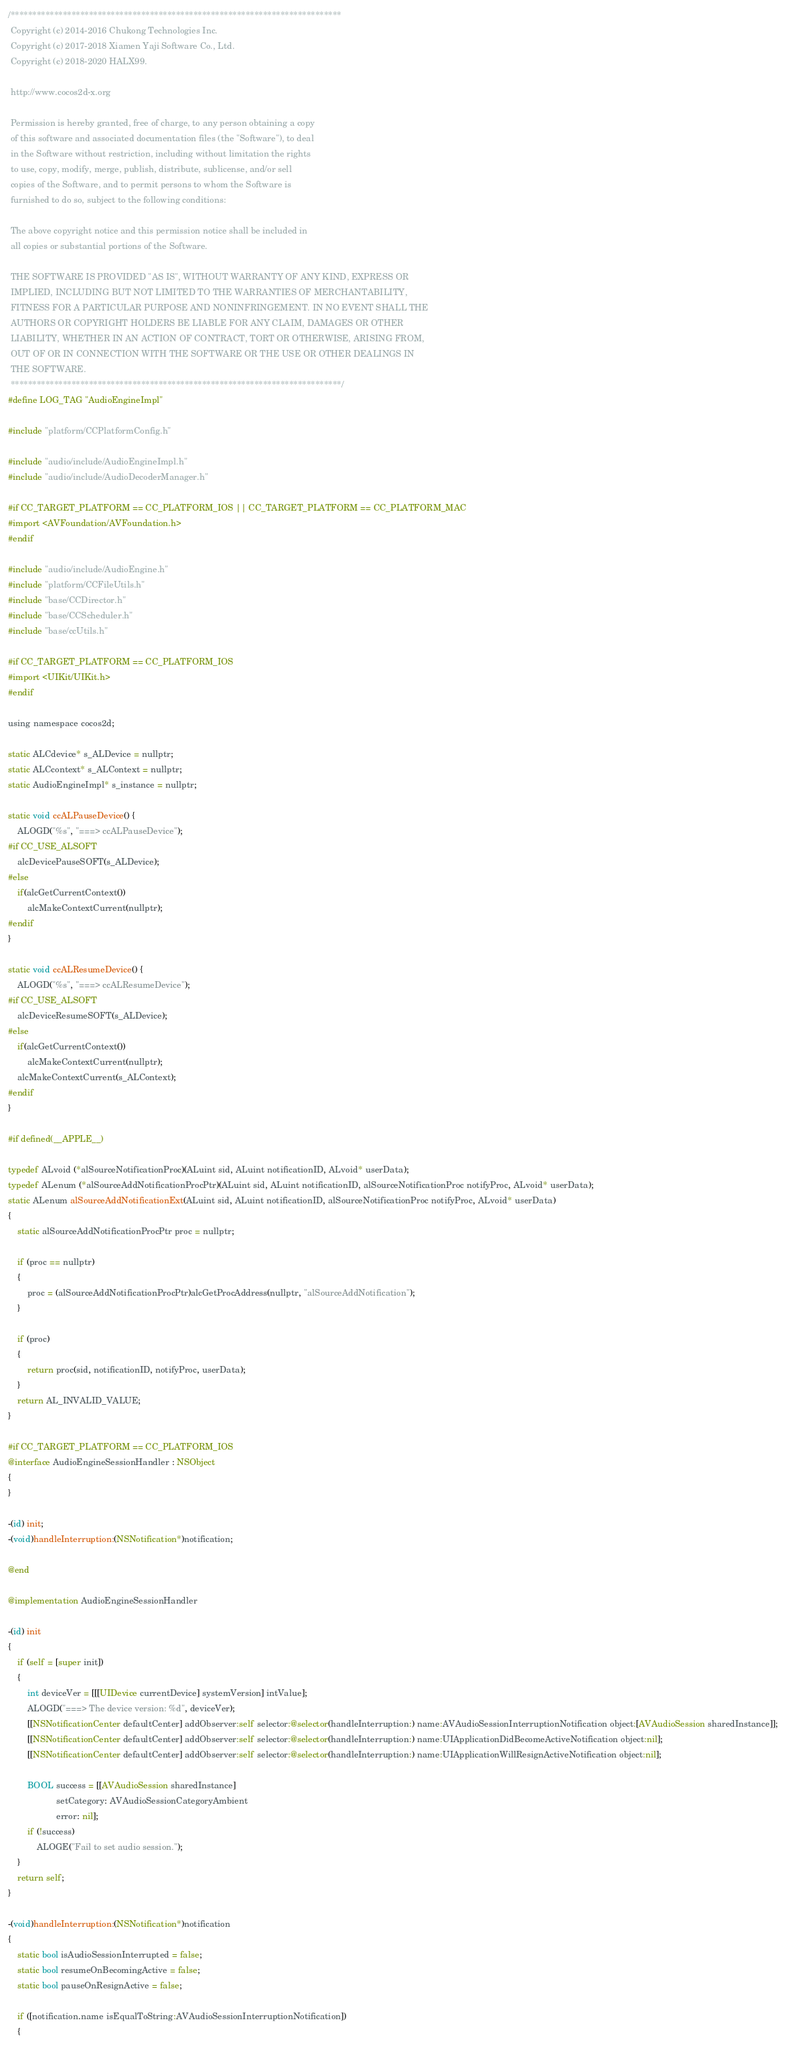<code> <loc_0><loc_0><loc_500><loc_500><_ObjectiveC_>/****************************************************************************
 Copyright (c) 2014-2016 Chukong Technologies Inc.
 Copyright (c) 2017-2018 Xiamen Yaji Software Co., Ltd.
 Copyright (c) 2018-2020 HALX99.

 http://www.cocos2d-x.org

 Permission is hereby granted, free of charge, to any person obtaining a copy
 of this software and associated documentation files (the "Software"), to deal
 in the Software without restriction, including without limitation the rights
 to use, copy, modify, merge, publish, distribute, sublicense, and/or sell
 copies of the Software, and to permit persons to whom the Software is
 furnished to do so, subject to the following conditions:

 The above copyright notice and this permission notice shall be included in
 all copies or substantial portions of the Software.

 THE SOFTWARE IS PROVIDED "AS IS", WITHOUT WARRANTY OF ANY KIND, EXPRESS OR
 IMPLIED, INCLUDING BUT NOT LIMITED TO THE WARRANTIES OF MERCHANTABILITY,
 FITNESS FOR A PARTICULAR PURPOSE AND NONINFRINGEMENT. IN NO EVENT SHALL THE
 AUTHORS OR COPYRIGHT HOLDERS BE LIABLE FOR ANY CLAIM, DAMAGES OR OTHER
 LIABILITY, WHETHER IN AN ACTION OF CONTRACT, TORT OR OTHERWISE, ARISING FROM,
 OUT OF OR IN CONNECTION WITH THE SOFTWARE OR THE USE OR OTHER DEALINGS IN
 THE SOFTWARE.
 ****************************************************************************/
#define LOG_TAG "AudioEngineImpl"

#include "platform/CCPlatformConfig.h"

#include "audio/include/AudioEngineImpl.h"
#include "audio/include/AudioDecoderManager.h"

#if CC_TARGET_PLATFORM == CC_PLATFORM_IOS || CC_TARGET_PLATFORM == CC_PLATFORM_MAC
#import <AVFoundation/AVFoundation.h>
#endif

#include "audio/include/AudioEngine.h"
#include "platform/CCFileUtils.h"
#include "base/CCDirector.h"
#include "base/CCScheduler.h"
#include "base/ccUtils.h"

#if CC_TARGET_PLATFORM == CC_PLATFORM_IOS
#import <UIKit/UIKit.h>
#endif

using namespace cocos2d;

static ALCdevice* s_ALDevice = nullptr;
static ALCcontext* s_ALContext = nullptr;
static AudioEngineImpl* s_instance = nullptr;

static void ccALPauseDevice() {
    ALOGD("%s", "===> ccALPauseDevice");
#if CC_USE_ALSOFT
    alcDevicePauseSOFT(s_ALDevice);
#else
    if(alcGetCurrentContext())
        alcMakeContextCurrent(nullptr);
#endif
}

static void ccALResumeDevice() {
    ALOGD("%s", "===> ccALResumeDevice");
#if CC_USE_ALSOFT
    alcDeviceResumeSOFT(s_ALDevice);
#else
    if(alcGetCurrentContext())
        alcMakeContextCurrent(nullptr);
    alcMakeContextCurrent(s_ALContext);
#endif
}

#if defined(__APPLE__)

typedef ALvoid (*alSourceNotificationProc)(ALuint sid, ALuint notificationID, ALvoid* userData);
typedef ALenum (*alSourceAddNotificationProcPtr)(ALuint sid, ALuint notificationID, alSourceNotificationProc notifyProc, ALvoid* userData);
static ALenum alSourceAddNotificationExt(ALuint sid, ALuint notificationID, alSourceNotificationProc notifyProc, ALvoid* userData)
{
    static alSourceAddNotificationProcPtr proc = nullptr;

    if (proc == nullptr)
    {
        proc = (alSourceAddNotificationProcPtr)alcGetProcAddress(nullptr, "alSourceAddNotification");
    }

    if (proc)
    {
        return proc(sid, notificationID, notifyProc, userData);
    }
    return AL_INVALID_VALUE;
}

#if CC_TARGET_PLATFORM == CC_PLATFORM_IOS
@interface AudioEngineSessionHandler : NSObject
{
}

-(id) init;
-(void)handleInterruption:(NSNotification*)notification;

@end

@implementation AudioEngineSessionHandler

-(id) init
{
    if (self = [super init])
    {
        int deviceVer = [[[UIDevice currentDevice] systemVersion] intValue];
        ALOGD("===> The device version: %d", deviceVer);
        [[NSNotificationCenter defaultCenter] addObserver:self selector:@selector(handleInterruption:) name:AVAudioSessionInterruptionNotification object:[AVAudioSession sharedInstance]];
        [[NSNotificationCenter defaultCenter] addObserver:self selector:@selector(handleInterruption:) name:UIApplicationDidBecomeActiveNotification object:nil];
        [[NSNotificationCenter defaultCenter] addObserver:self selector:@selector(handleInterruption:) name:UIApplicationWillResignActiveNotification object:nil];

        BOOL success = [[AVAudioSession sharedInstance]
                    setCategory: AVAudioSessionCategoryAmbient
                    error: nil];
        if (!success)
            ALOGE("Fail to set audio session.");
    }
    return self;
}

-(void)handleInterruption:(NSNotification*)notification
{
    static bool isAudioSessionInterrupted = false;
    static bool resumeOnBecomingActive = false;
    static bool pauseOnResignActive = false;

    if ([notification.name isEqualToString:AVAudioSessionInterruptionNotification])
    {</code> 